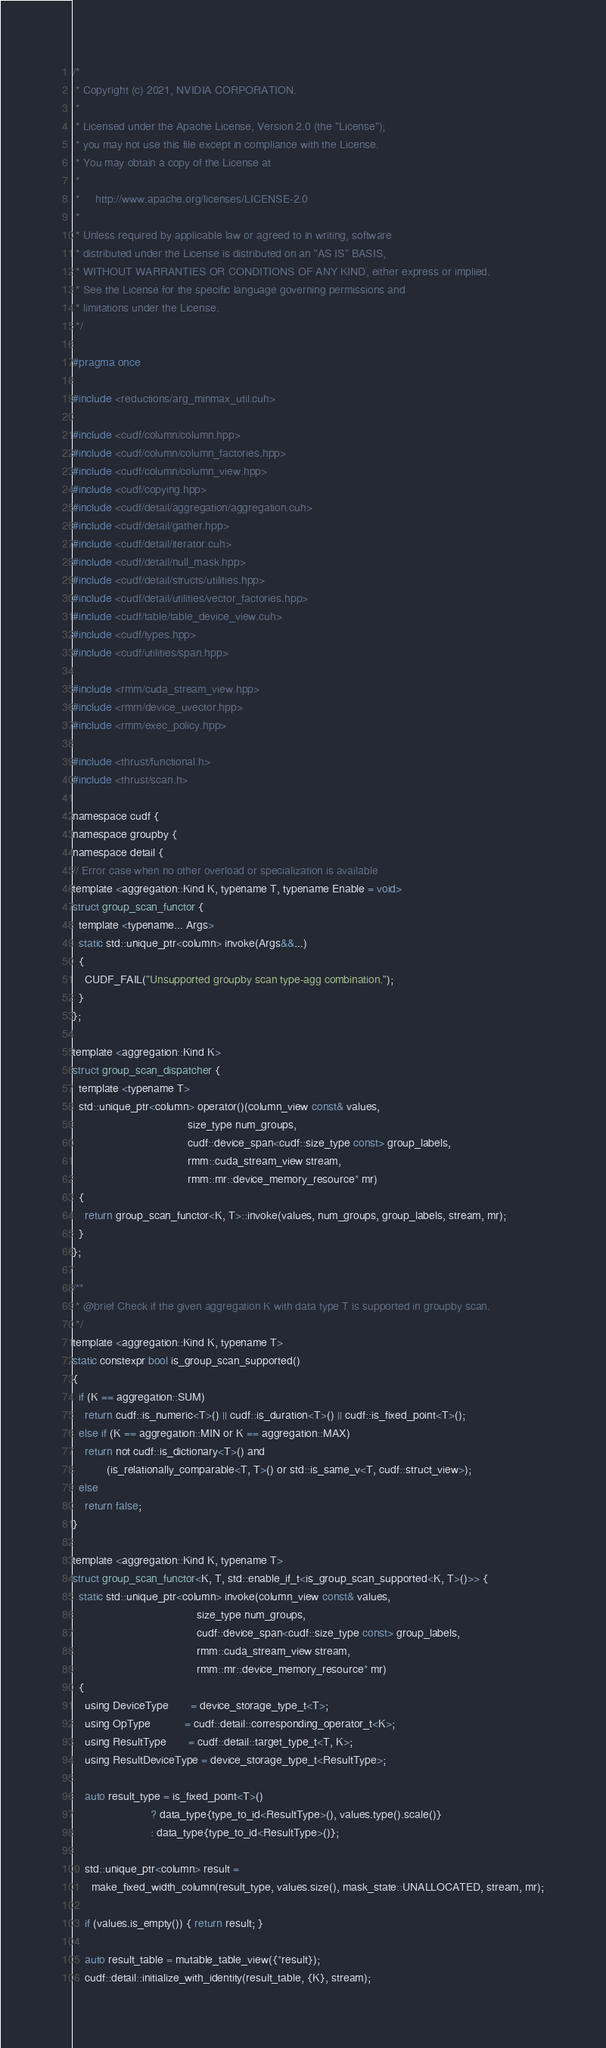Convert code to text. <code><loc_0><loc_0><loc_500><loc_500><_Cuda_>/*
 * Copyright (c) 2021, NVIDIA CORPORATION.
 *
 * Licensed under the Apache License, Version 2.0 (the "License");
 * you may not use this file except in compliance with the License.
 * You may obtain a copy of the License at
 *
 *     http://www.apache.org/licenses/LICENSE-2.0
 *
 * Unless required by applicable law or agreed to in writing, software
 * distributed under the License is distributed on an "AS IS" BASIS,
 * WITHOUT WARRANTIES OR CONDITIONS OF ANY KIND, either express or implied.
 * See the License for the specific language governing permissions and
 * limitations under the License.
 */

#pragma once

#include <reductions/arg_minmax_util.cuh>

#include <cudf/column/column.hpp>
#include <cudf/column/column_factories.hpp>
#include <cudf/column/column_view.hpp>
#include <cudf/copying.hpp>
#include <cudf/detail/aggregation/aggregation.cuh>
#include <cudf/detail/gather.hpp>
#include <cudf/detail/iterator.cuh>
#include <cudf/detail/null_mask.hpp>
#include <cudf/detail/structs/utilities.hpp>
#include <cudf/detail/utilities/vector_factories.hpp>
#include <cudf/table/table_device_view.cuh>
#include <cudf/types.hpp>
#include <cudf/utilities/span.hpp>

#include <rmm/cuda_stream_view.hpp>
#include <rmm/device_uvector.hpp>
#include <rmm/exec_policy.hpp>

#include <thrust/functional.h>
#include <thrust/scan.h>

namespace cudf {
namespace groupby {
namespace detail {
// Error case when no other overload or specialization is available
template <aggregation::Kind K, typename T, typename Enable = void>
struct group_scan_functor {
  template <typename... Args>
  static std::unique_ptr<column> invoke(Args&&...)
  {
    CUDF_FAIL("Unsupported groupby scan type-agg combination.");
  }
};

template <aggregation::Kind K>
struct group_scan_dispatcher {
  template <typename T>
  std::unique_ptr<column> operator()(column_view const& values,
                                     size_type num_groups,
                                     cudf::device_span<cudf::size_type const> group_labels,
                                     rmm::cuda_stream_view stream,
                                     rmm::mr::device_memory_resource* mr)
  {
    return group_scan_functor<K, T>::invoke(values, num_groups, group_labels, stream, mr);
  }
};

/**
 * @brief Check if the given aggregation K with data type T is supported in groupby scan.
 */
template <aggregation::Kind K, typename T>
static constexpr bool is_group_scan_supported()
{
  if (K == aggregation::SUM)
    return cudf::is_numeric<T>() || cudf::is_duration<T>() || cudf::is_fixed_point<T>();
  else if (K == aggregation::MIN or K == aggregation::MAX)
    return not cudf::is_dictionary<T>() and
           (is_relationally_comparable<T, T>() or std::is_same_v<T, cudf::struct_view>);
  else
    return false;
}

template <aggregation::Kind K, typename T>
struct group_scan_functor<K, T, std::enable_if_t<is_group_scan_supported<K, T>()>> {
  static std::unique_ptr<column> invoke(column_view const& values,
                                        size_type num_groups,
                                        cudf::device_span<cudf::size_type const> group_labels,
                                        rmm::cuda_stream_view stream,
                                        rmm::mr::device_memory_resource* mr)
  {
    using DeviceType       = device_storage_type_t<T>;
    using OpType           = cudf::detail::corresponding_operator_t<K>;
    using ResultType       = cudf::detail::target_type_t<T, K>;
    using ResultDeviceType = device_storage_type_t<ResultType>;

    auto result_type = is_fixed_point<T>()
                         ? data_type{type_to_id<ResultType>(), values.type().scale()}
                         : data_type{type_to_id<ResultType>()};

    std::unique_ptr<column> result =
      make_fixed_width_column(result_type, values.size(), mask_state::UNALLOCATED, stream, mr);

    if (values.is_empty()) { return result; }

    auto result_table = mutable_table_view({*result});
    cudf::detail::initialize_with_identity(result_table, {K}, stream);
</code> 